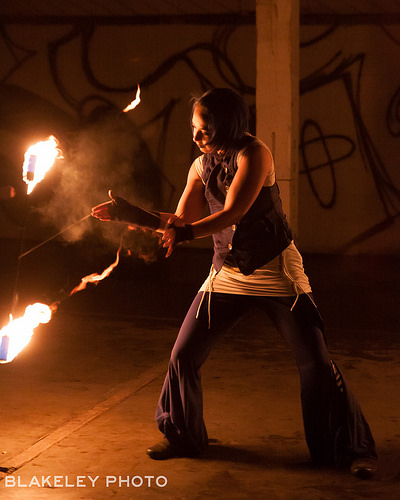<image>
Is the person next to the fire? Yes. The person is positioned adjacent to the fire, located nearby in the same general area. 